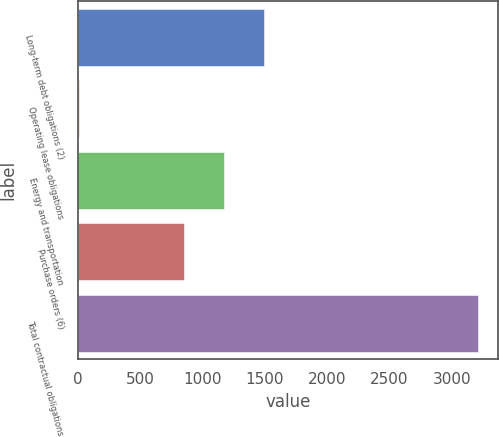Convert chart to OTSL. <chart><loc_0><loc_0><loc_500><loc_500><bar_chart><fcel>Long-term debt obligations (2)<fcel>Operating lease obligations<fcel>Energy and transportation<fcel>Purchase orders (6)<fcel>Total contractual obligations<nl><fcel>1491.56<fcel>9.5<fcel>1171.43<fcel>851.3<fcel>3210.8<nl></chart> 